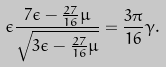Convert formula to latex. <formula><loc_0><loc_0><loc_500><loc_500>\epsilon \frac { 7 \epsilon - \frac { 2 7 } { 1 6 } \mu } { \sqrt { 3 \epsilon - \frac { 2 7 } { 1 6 } \mu } } = \frac { 3 \pi } { 1 6 } \gamma .</formula> 